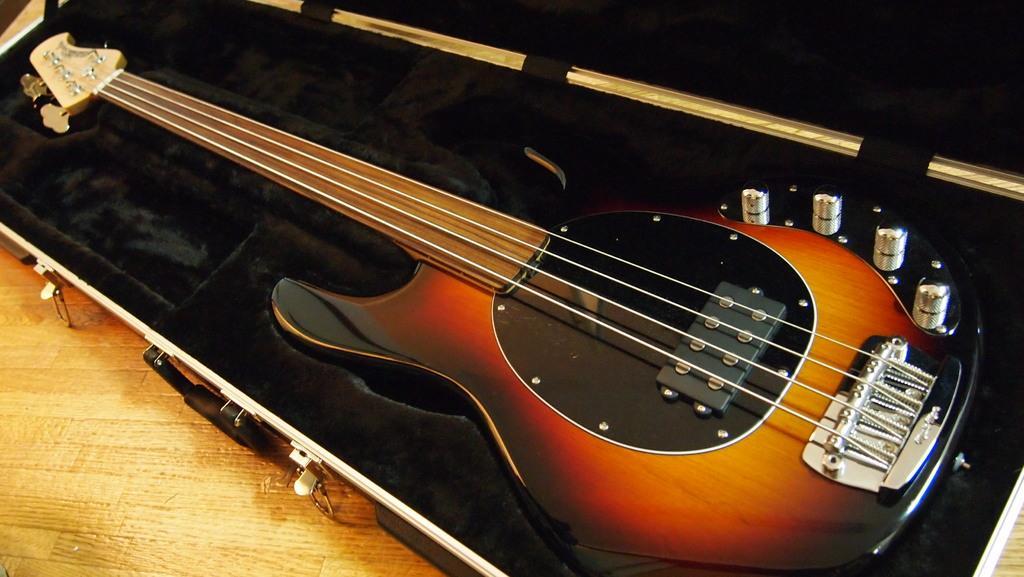In one or two sentences, can you explain what this image depicts? In this picture we can see guitar where this is placed in a box. 